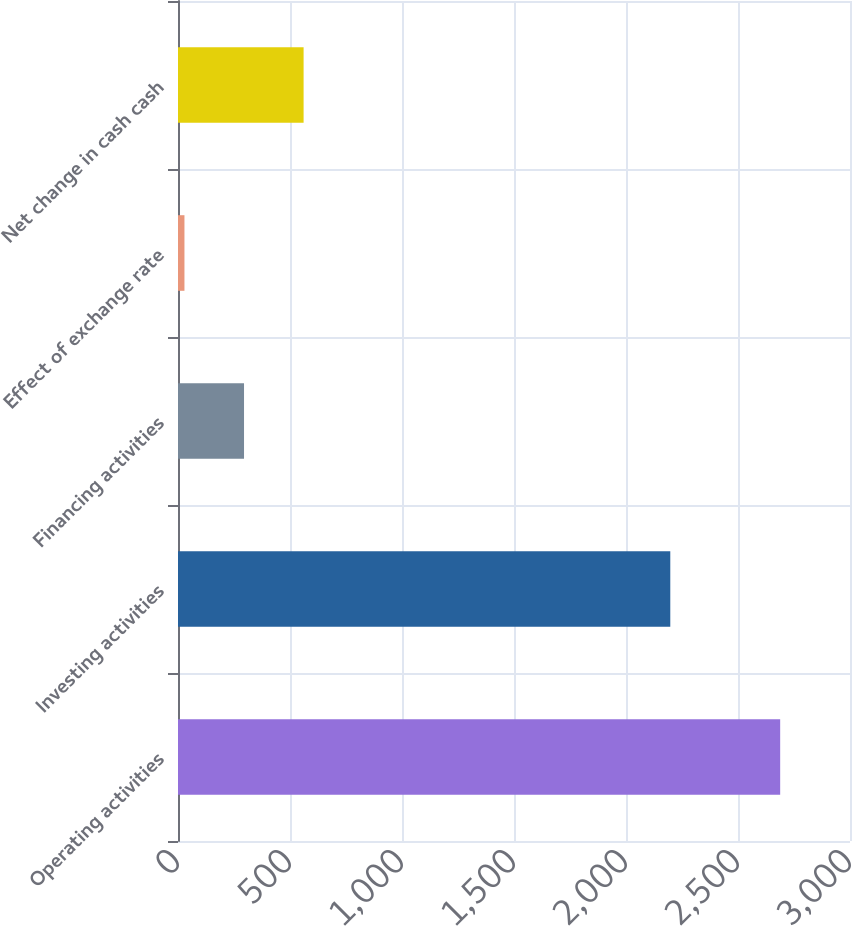Convert chart to OTSL. <chart><loc_0><loc_0><loc_500><loc_500><bar_chart><fcel>Operating activities<fcel>Investing activities<fcel>Financing activities<fcel>Effect of exchange rate<fcel>Net change in cash cash<nl><fcel>2688.3<fcel>2197.7<fcel>294.75<fcel>28.8<fcel>560.7<nl></chart> 